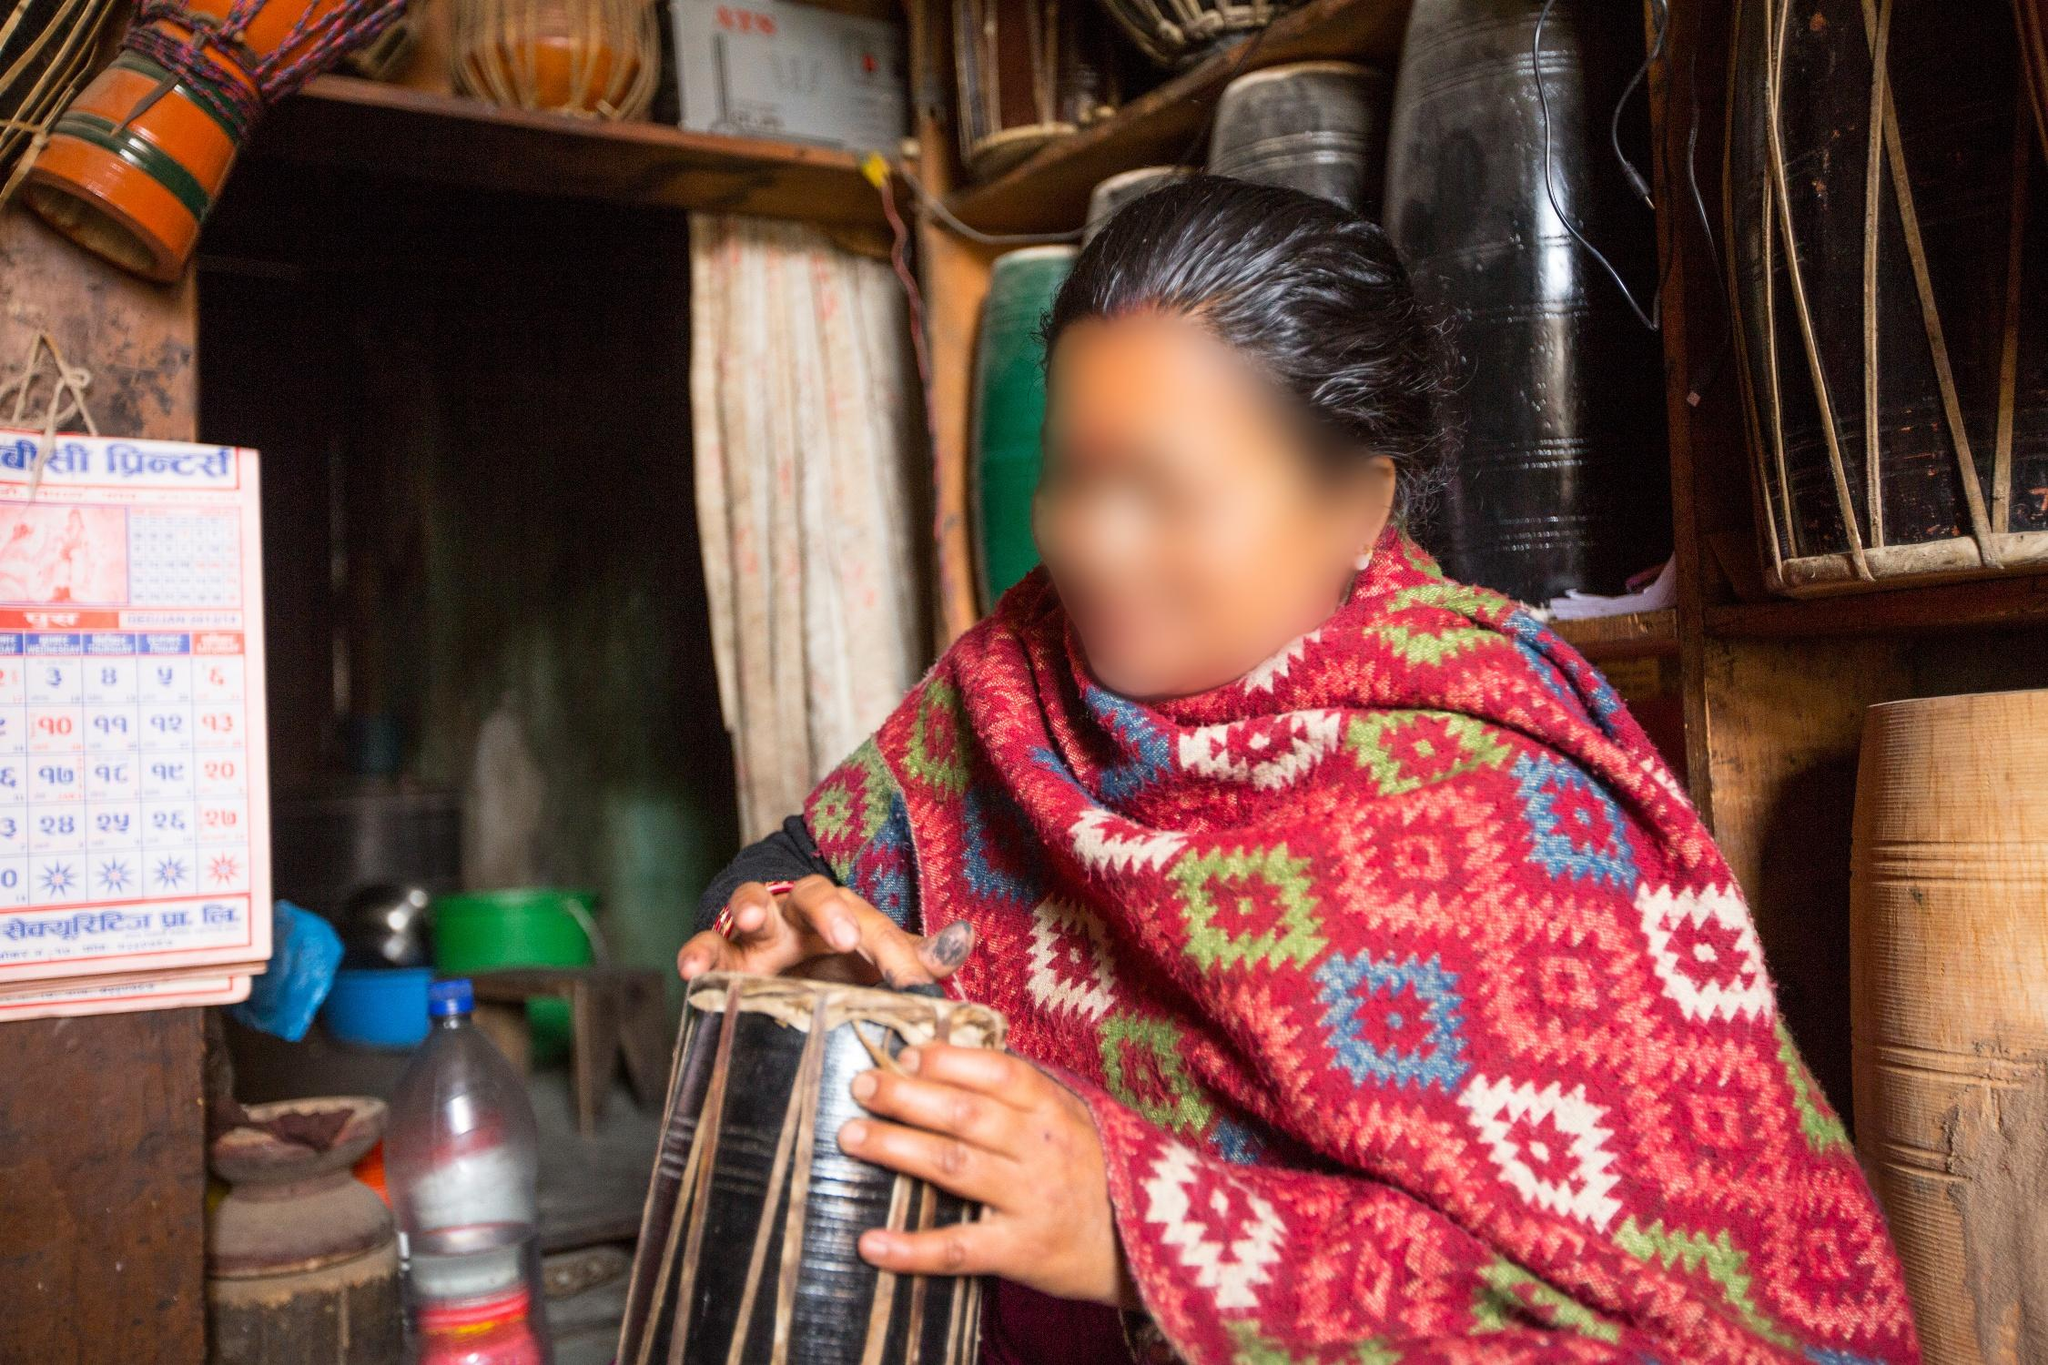Imagine you could interact with the shop owner. What would you ask them about their life and their shop? I would ask the shop owner about the history of their shop and the types of customers they serve daily. I would be curious to know about the significance of the madal and other traditional items they sell. I would also ask about their life experiences, their role in the community, and how they have seen cultural practices evolve over the years in this small town. Could you describe a day in the life of the shop owner? A day in the life of the shop owner likely starts early with cleaning and organizing the shop, ensuring all goods are well-arranged and ready for customers. They might spend the morning stocking items and chatting with the first few customers of the day. As the day progresses, the shop may see a steady flow of local patrons, some of whom might linger to listen to the shop owner playing the madal. The shop owner might also have moments of solitude where they reflect on their connection to their cultural roots while performing mundane tasks like inventory management or arranging new stock. The day concludes with closing up the shop and perhaps prepping for the next day. Despite the routine, each day is filled with small moments of personal interaction and cultural preservation. If we could turn back time, what historical events might this shop have witnessed? This shop might have witnessed numerous local festivals, celebrations, and social gatherings, providing a backdrop to significant cultural events over the years. It could have seen the transition from a more traditional lifestyle to a blend of modern influences. The shop might have been a silent observer to folk tales, local developments, and perhaps even important moments in Nepal's history, such as political changes or social movements. Each item on its shelves and each beat of the madal could weave a tapestry of the local community's heritage and resilience. If the madal could speak, what would it say about its journey and its role in the community? If the madal could speak, it would likely share stories of joyful celebrations and community gatherings where its rhythms provided the heartbeat of festivities. It might recount how it has been passed down through generations, becoming an heirloom that carries with it the spirit of Nepali music. The madal would speak of its role in rituals, storytelling, and cultural preservation, serving as a bridge between the past and present. It might also express pride in being a symbol of cultural identity and a source of joy and connection amongst the people. 